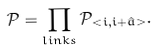Convert formula to latex. <formula><loc_0><loc_0><loc_500><loc_500>\mathcal { P } = \prod _ { l i n k s } \mathcal { P } _ { < { i , i + \hat { a } } > } .</formula> 